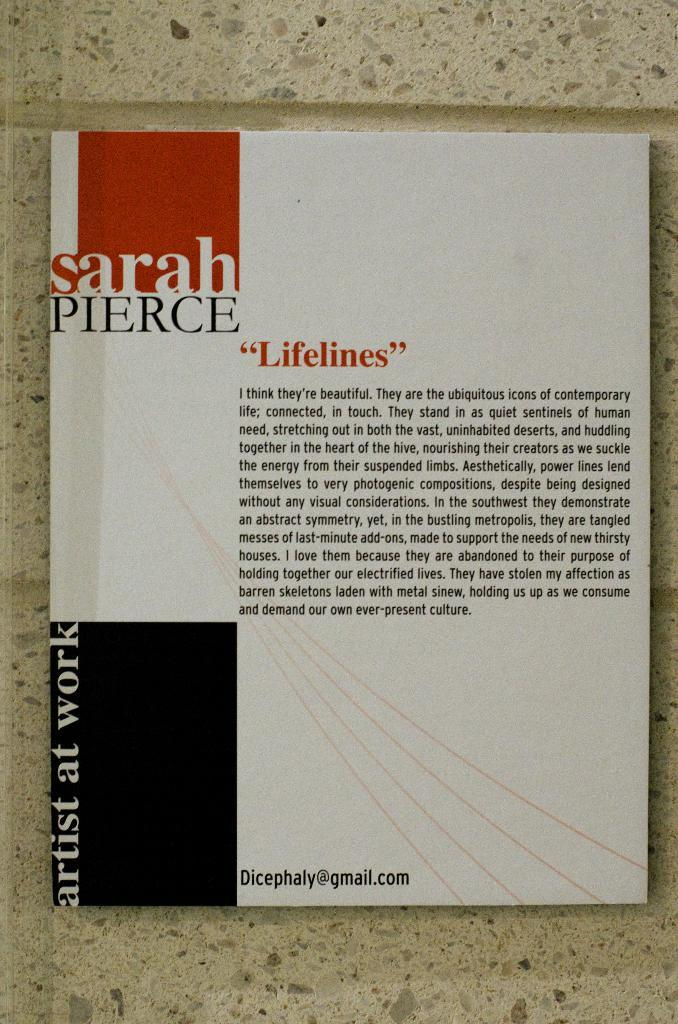<image>
Present a compact description of the photo's key features. A book by Sarah Pierce is titled Lifelines. 